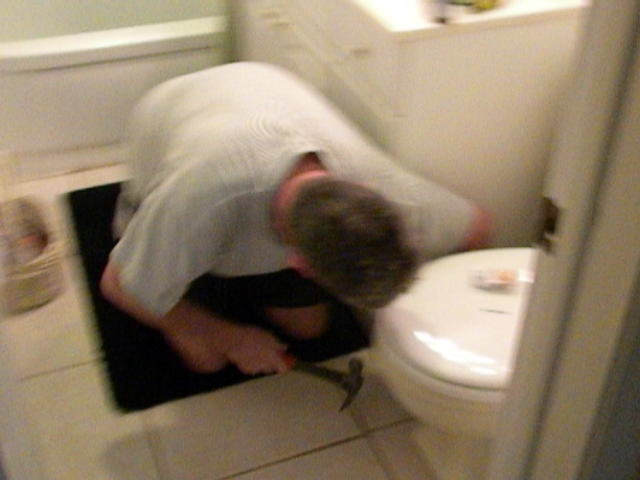Describe the objects in this image and their specific colors. I can see people in tan, black, gray, maroon, and lightgray tones and toilet in tan, ivory, and gray tones in this image. 